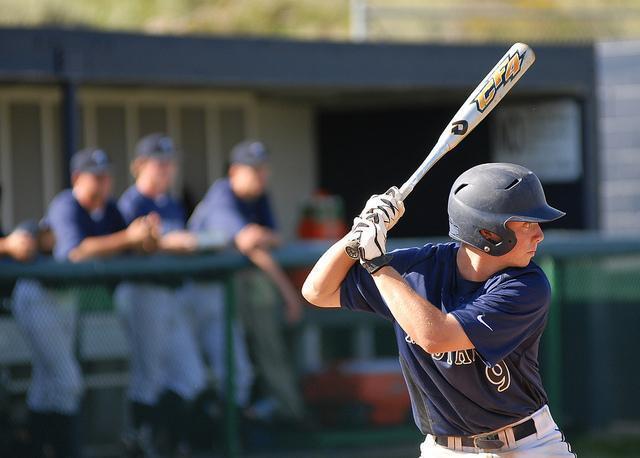How many players are in the picture?
Give a very brief answer. 4. How many people are in the photo?
Give a very brief answer. 4. 